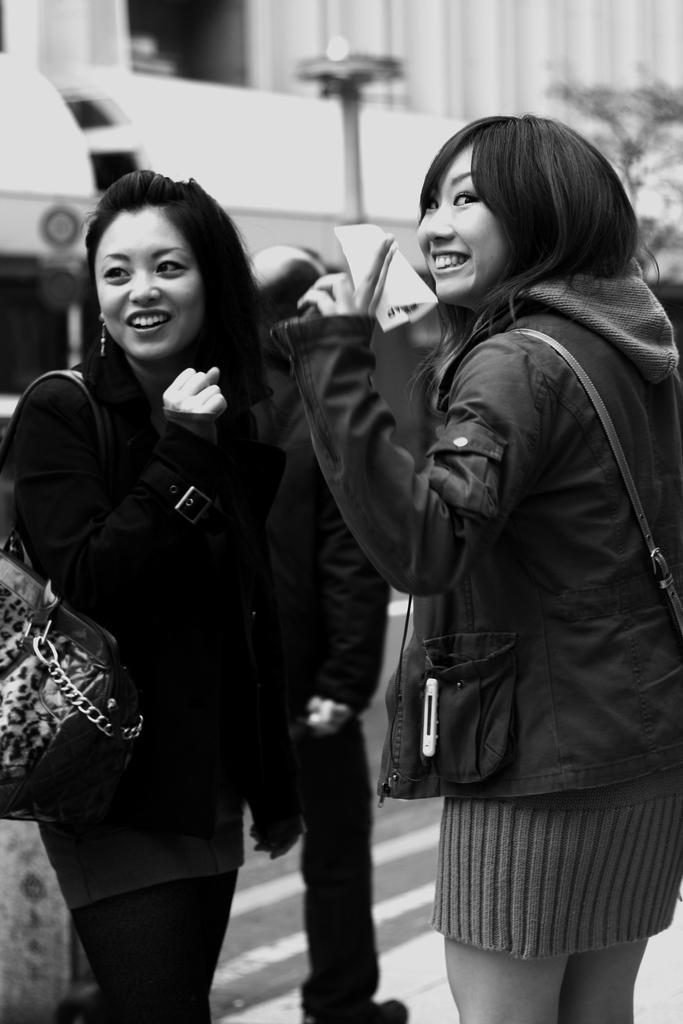Please provide a concise description of this image. This is a black and white image there are two ladies standing. There is a person walking. In the background of the image there is a building. There is a pole. 